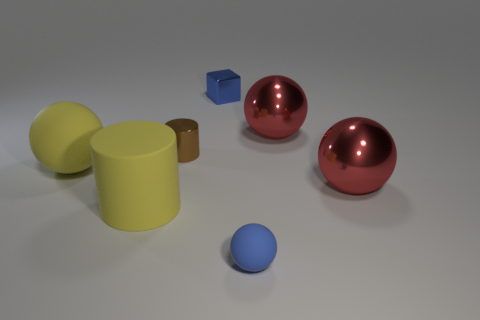Add 2 big gray cylinders. How many objects exist? 9 Subtract 2 balls. How many balls are left? 2 Subtract all yellow cylinders. How many cylinders are left? 1 Subtract all small blue balls. How many balls are left? 3 Subtract all balls. How many objects are left? 3 Add 3 small metal blocks. How many small metal blocks are left? 4 Add 4 small cubes. How many small cubes exist? 5 Subtract 0 red blocks. How many objects are left? 7 Subtract all brown cylinders. Subtract all purple cubes. How many cylinders are left? 1 Subtract all brown cylinders. How many gray balls are left? 0 